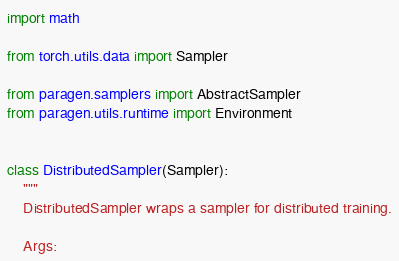Convert code to text. <code><loc_0><loc_0><loc_500><loc_500><_Python_>import math

from torch.utils.data import Sampler

from paragen.samplers import AbstractSampler
from paragen.utils.runtime import Environment


class DistributedSampler(Sampler):
    """
    DistributedSampler wraps a sampler for distributed training.

    Args:</code> 